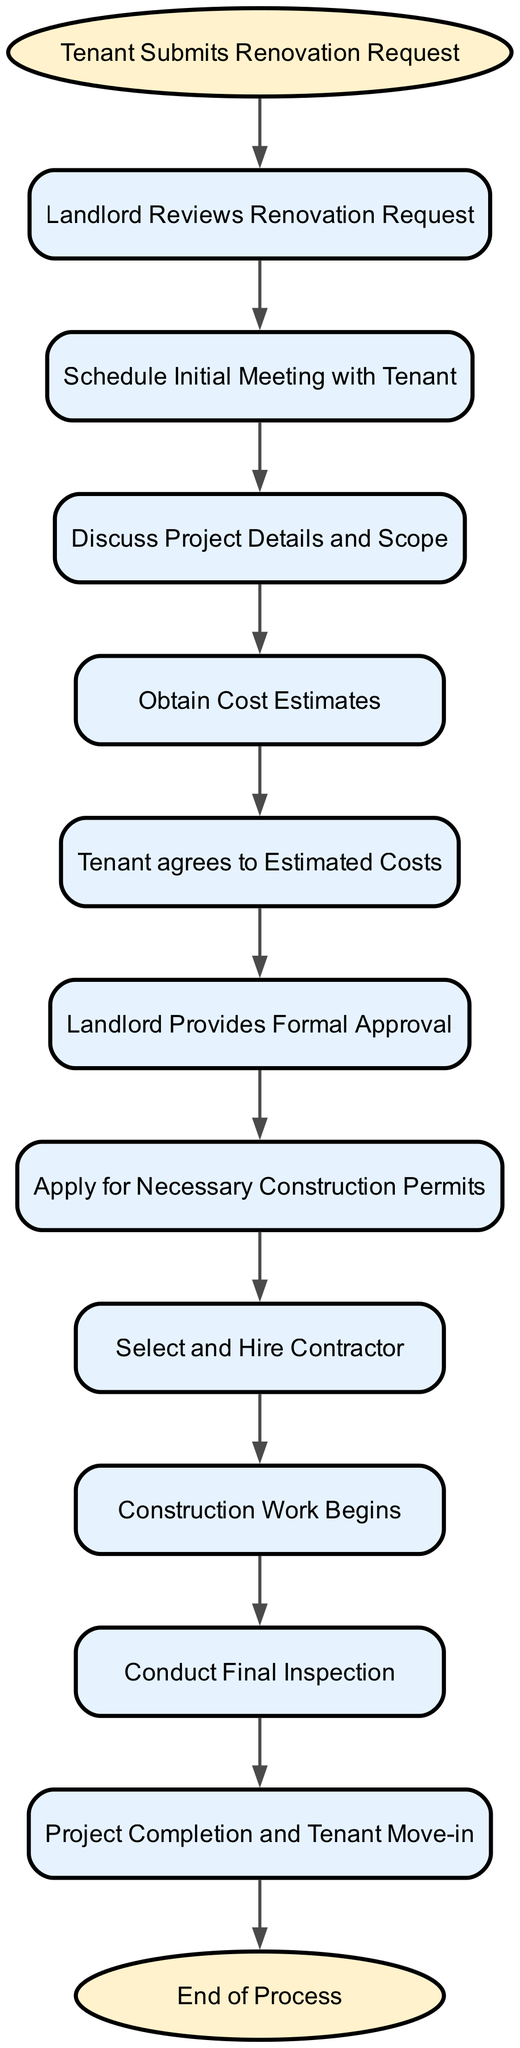What is the first step in the renovation request process? The first step in the process is indicated by the 'start' node, which states "Tenant Submits Renovation Request". This is the action that initiates the entire flow of the diagram.
Answer: Tenant Submits Renovation Request How many nodes are there in total? By counting all the unique elements listed in the diagram, we find there are 13 nodes, including both the starting and ending points of the process.
Answer: 13 What happens immediately after the landlord reviews the renovation request? Following the 'Landlord Reviews Renovation Request', the next step is to 'Schedule Initial Meeting with Tenant', which indicates progress to the next phase of the process.
Answer: Schedule Initial Meeting with Tenant What must the tenant do after obtaining cost estimates? After 'Obtain Cost Estimates', the flow indicates that the next action required is for the 'Tenant agrees to Estimated Costs', showing that the tenant must provide their agreement before proceeding with the project.
Answer: Tenant agrees to Estimated Costs What is the last step before project completion? The last step indicated before reaching 'Project Completion and Tenant Move-in' is 'Conduct Final Inspection'. This confirms that the project meets standards prior to completion.
Answer: Conduct Final Inspection Which step involves selecting a contractor? The node labeled 'Select and Hire Contractor' is specifically about the step in which a contractor is chosen for the renovation, following the approval of necessary permits.
Answer: Select and Hire Contractor How many connections are there in the diagram? By counting the number of connections (edges) that illustrate the flow from one step to the next throughout the diagram, we find there are 12 connections in total.
Answer: 12 What is the purpose of applying for construction permits? The step labeled 'Apply for Necessary Construction Permits' is crucial as it ensures that building regulations are followed, allowing the project to proceed legally and safely after landlord approval.
Answer: Apply for Necessary Construction Permits Which node comes before the 'Construction Work Begins' node? The node directly preceding 'Construction Work Begins' is 'Select and Hire Contractor', indicating that selecting the contractor is a prerequisite to starting construction on the project.
Answer: Select and Hire Contractor 